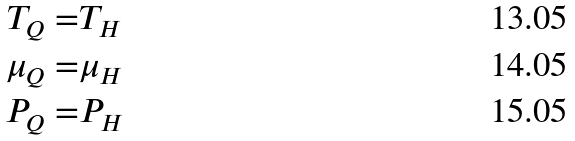Convert formula to latex. <formula><loc_0><loc_0><loc_500><loc_500>T _ { Q } = & T _ { H } \\ \mu _ { Q } = & \mu _ { H } \\ P _ { Q } = & P _ { H }</formula> 